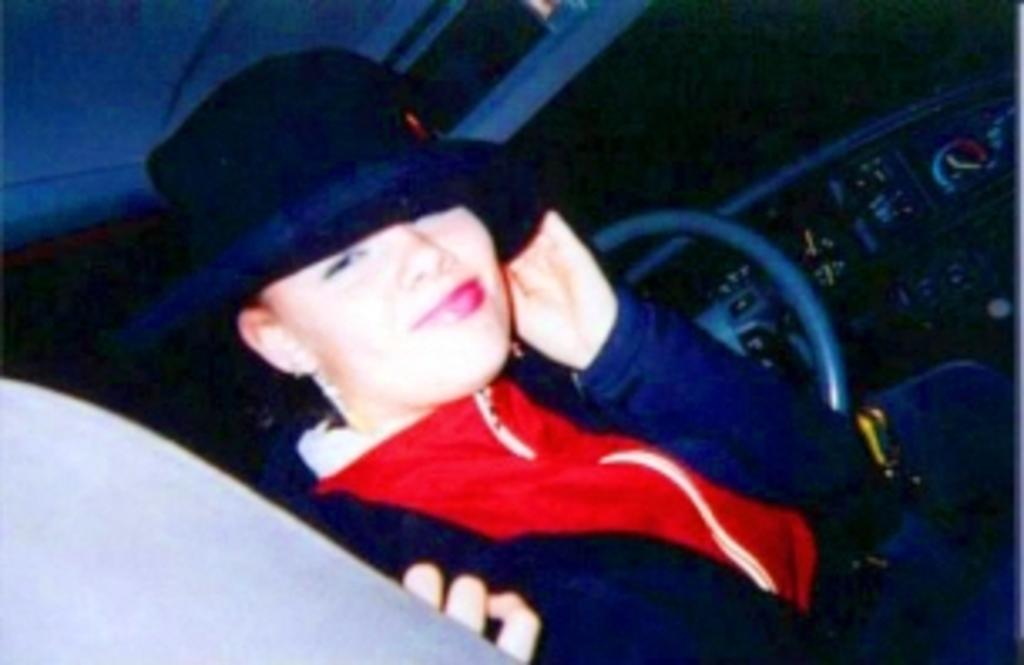What type of motor vehicle is in the image? The specific type of motor vehicle is not mentioned, but there is a motor vehicle present in the image. Who is in the image besides the motor vehicle? There is a woman in the image. What type of comb is the woman using in the image? There is no comb present in the image. Is there any smoke visible in the image? There is no mention of smoke in the image, so it cannot be determined if it is present or not. 